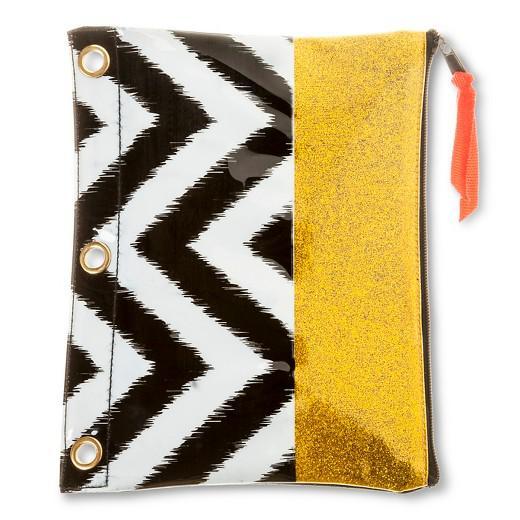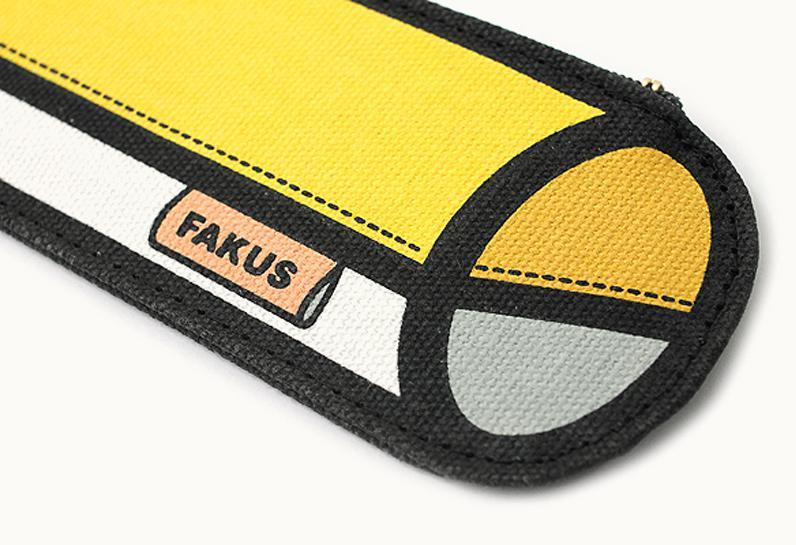The first image is the image on the left, the second image is the image on the right. For the images shown, is this caption "A school supply has a print of a cartoon face in one of the images." true? Answer yes or no. No. The first image is the image on the left, the second image is the image on the right. Examine the images to the left and right. Is the description "A zipper case has a black-and-white zig zag pattern on the bottom and a yellowish band across the top." accurate? Answer yes or no. Yes. 